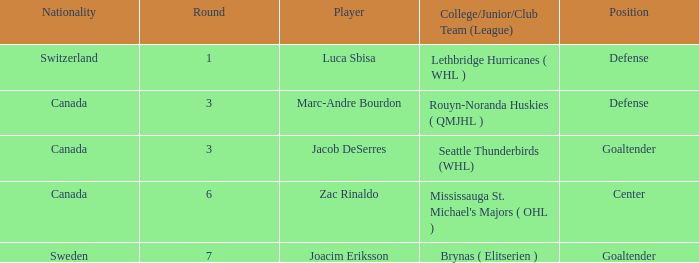What position did Luca Sbisa play for the Philadelphia Flyers? Defense. 